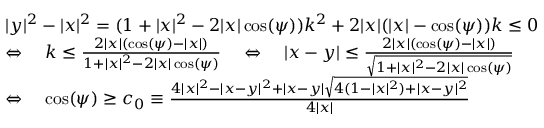<formula> <loc_0><loc_0><loc_500><loc_500>\begin{array} { r l } & { | y | ^ { 2 } - | x | ^ { 2 } = ( 1 + | x | ^ { 2 } - 2 | x | \cos ( \psi ) ) k ^ { 2 } + 2 | x | ( | x | - \cos ( \psi ) ) k \leq 0 } \\ & { \Leftrightarrow \quad k \leq \frac { 2 | x | ( \cos ( \psi ) - | x | ) } { 1 + | x | ^ { 2 } - 2 | x | \cos ( \psi ) } \quad \Leftrightarrow \quad | x - y | \leq \frac { 2 | x | ( \cos ( \psi ) - | x | ) } { \sqrt { 1 + | x | ^ { 2 } - 2 | x | \cos ( \psi ) } } } \\ & { \Leftrightarrow \quad \cos ( \psi ) \geq c _ { 0 } \equiv \frac { 4 | x | ^ { 2 } - | x - y | ^ { 2 } + | x - y | \sqrt { 4 ( 1 - | x | ^ { 2 } ) + | x - y | ^ { 2 } } } { 4 | x | } } \end{array}</formula> 